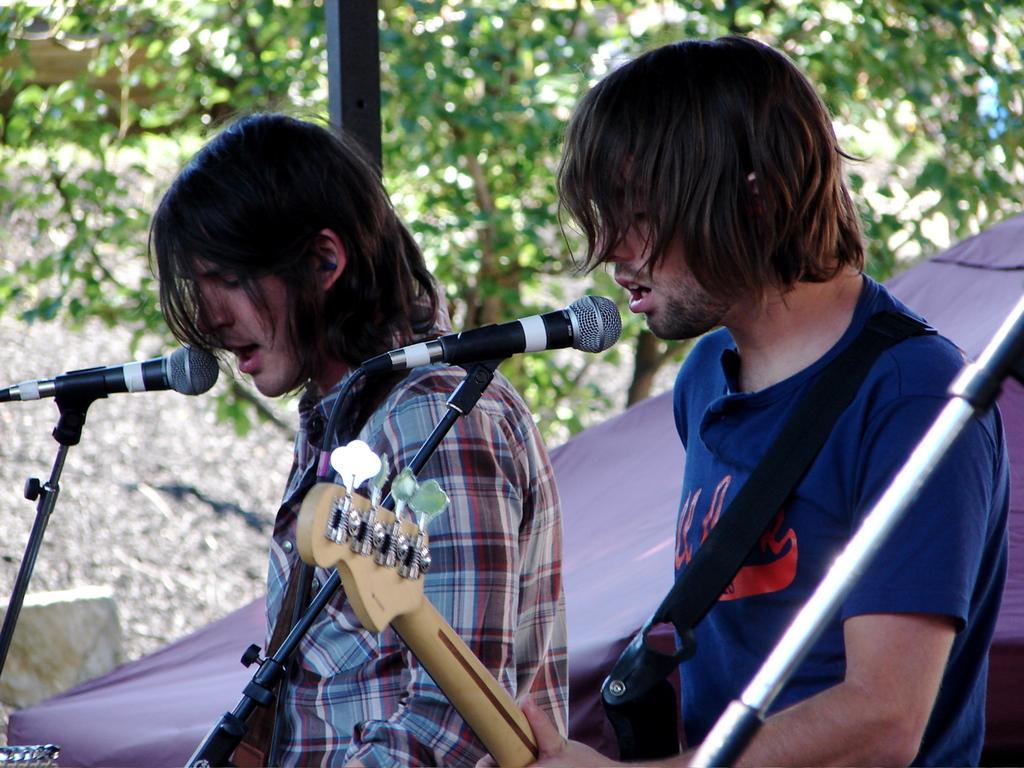How many people are in the image? There are two persons in the image. What are the persons doing in the image? The persons are playing musical instruments and singing a song. What can be seen in the background of the image? Trees and cloth are visible in the background of the image. What type of rice can be seen in the image? There is no rice present in the image. Is there any motion detected in the locket in the image? There is no locket present in the image. 